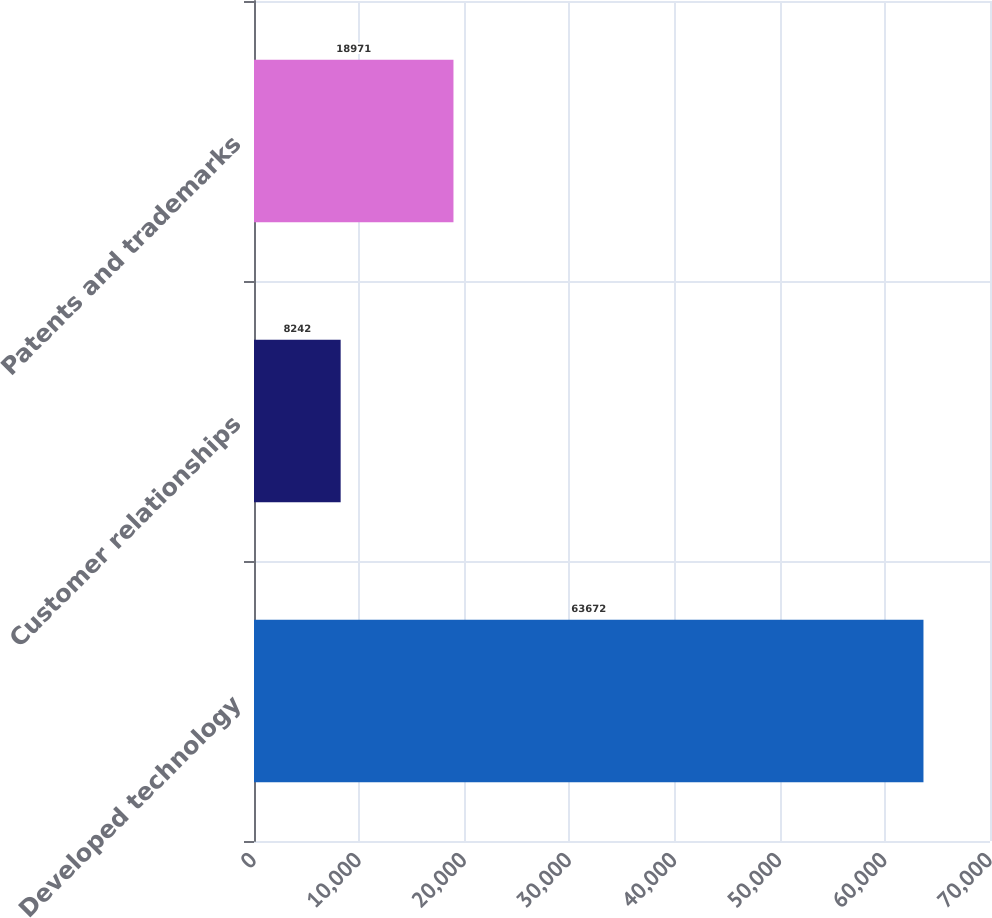Convert chart. <chart><loc_0><loc_0><loc_500><loc_500><bar_chart><fcel>Developed technology<fcel>Customer relationships<fcel>Patents and trademarks<nl><fcel>63672<fcel>8242<fcel>18971<nl></chart> 